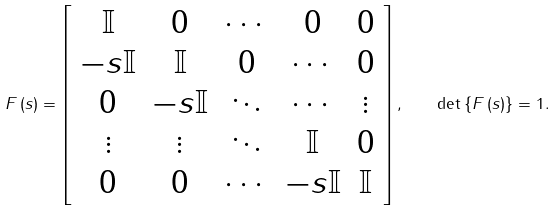Convert formula to latex. <formula><loc_0><loc_0><loc_500><loc_500>F \left ( s \right ) = \left [ \begin{array} { c c c c c } \mathbb { I } & 0 & \cdots & 0 & 0 \\ - s \mathbb { I } & \mathbb { I } & 0 & \cdots & 0 \\ 0 & - s \mathbb { I } & \ddots & \cdots & \vdots \\ \vdots & \vdots & \ddots & \mathbb { I } & 0 \\ 0 & 0 & \cdots & - s \mathbb { I } & \mathbb { I } \end{array} \right ] , \quad \det \left \{ F \left ( s \right ) \right \} = 1 .</formula> 